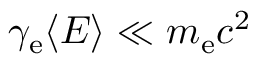<formula> <loc_0><loc_0><loc_500><loc_500>\gamma _ { e } \langle E \rangle \ll m _ { e } c ^ { 2 }</formula> 